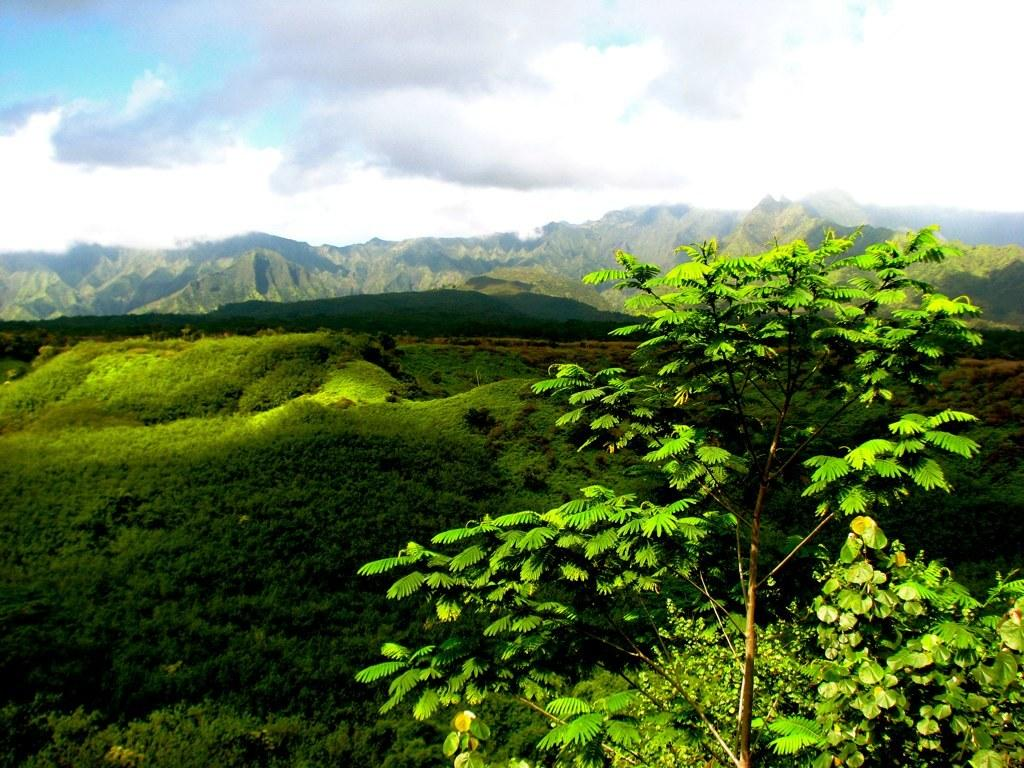What is the condition of the sky in the image? The sky is cloudy in the image. What can be seen in the distance in the image? There are mountains in the distance in the image. What type of vegetation is present in the image? There is grass in the image. What type of plant is visible in the image? There is a tree in the image. Where is the fireman located in the image? There is no fireman present in the image. How many pigs can be seen playing in the grass in the image? There are no pigs present in the image. 